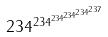<formula> <loc_0><loc_0><loc_500><loc_500>2 3 4 ^ { 2 3 4 ^ { 2 3 4 ^ { 2 3 4 ^ { 2 3 4 ^ { 2 3 7 } } } } }</formula> 